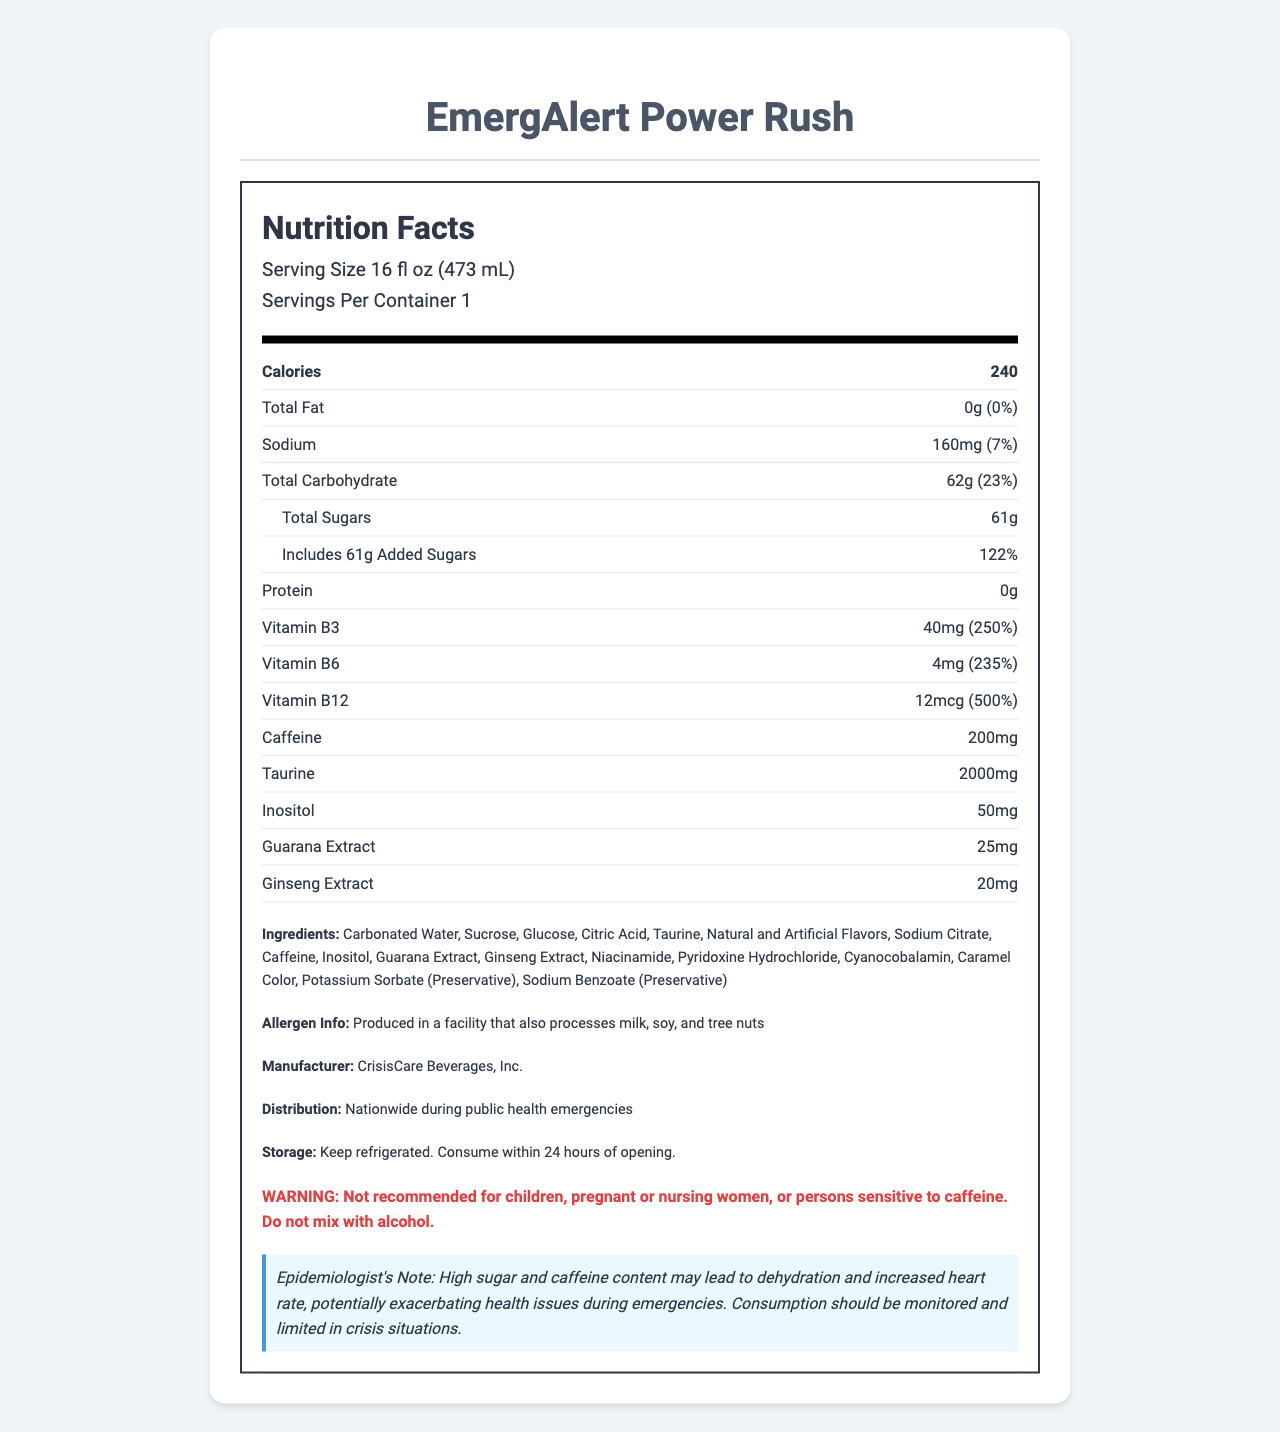what is the serving size for EmergAlert Power Rush? The serving size is clearly listed under the product name in the nutrition facts section.
Answer: 16 fl oz (473 mL) how many calories are in one serving of EmergAlert Power Rush? The calories are listed in bold within the nutrient information.
Answer: 240 calories what is the total carbohydrate content and its daily value percentage per serving? This information is listed together in the nutrient row for Total Carbohydrate.
Answer: 62g, 23% which vitamins are enriched in EmergAlert Power Rush? The vitamins and their amounts with daily value percentages are listed in the nutrient section.
Answer: Vitamin B3, Vitamin B6, Vitamin B12 how much caffeine is in a serving of EmergAlert Power Rush? This information can be found near the end of the nutrient section.
Answer: 200mg is there any protein in EmergAlert Power Rush? The document lists the protein content as 0g.
Answer: No how many grams of added sugars are in one serving, and what percentage of daily value does it represent? This information is listed under Total Sugars and Included Added Sugars in the nutrient section.
Answer: 61g, 122% what ingredients are used in EmergAlert Power Rush? The ingredients list is provided at the end of the document.
Answer: Carbonated Water, Sucrose, Glucose, Citric Acid, Taurine, Natural and Artificial Flavors, Sodium Citrate, Caffeine, Inositol, Guarana Extract, Ginseng Extract, Niacinamide, Pyridoxine Hydrochloride, Cyanocobalamin, Caramel Color, Potassium Sorbate (Preservative), Sodium Benzoate (Preservative) is EmergAlert Power Rush recommended for children? The warning section states that it is not recommended for children.
Answer: No which extract is present in a lesser amount in EmergAlert Power Rush? A. Guarana Extract B. Taurine C. Ginseng Extract D. Inositol The nutrient row lists Guarana Extract as 25mg and Ginseng Extract as 20mg, making Ginseng Extract the lesser amount.
Answer: C. Ginseng Extract what is the function of Potassium Sorbate in EmergAlert Power Rush? A. Enhance flavor B. Provide energy C. Act as a preservative D. Increase caffeine content The ingredients section mentions Potassium Sorbate with a note that it is a preservative.
Answer: C. Act as a preservative does EmergAlert Power Rush contain any allergens? The allergen information states that it is produced in a facility that also processes milk, soy, and tree nuts.
Answer: Yes summarize the main idea of the document. The document provides detailed nutrition facts, ingredient information, warnings, and additional notes about the product, emphasizing its energy-boosting properties and high sugar and caffeine content.
Answer: EmergAlert Power Rush is an energy drink with high calorie, carbohydrate, and sugar content, providing substantial doses of Vitamin B3, B6, and B12. It contains significant caffeine and other energy-boosting ingredients like taurine, ginseng extract, and guarana extract. The product is distributed during public health emergencies, comes with specific storage instructions, and carries a warning against consumption by certain groups. why is taurine included in EmergAlert Power Rush? The document lists taurine as an ingredient but does not provide a specific reason for its inclusion.
Answer: Cannot be determined what is the daily value percentage of Vitamin B12 in one serving of EmergAlert Power Rush? The daily value percentage for Vitamin B12 is clearly listed in the nutrient section.
Answer: 500% 